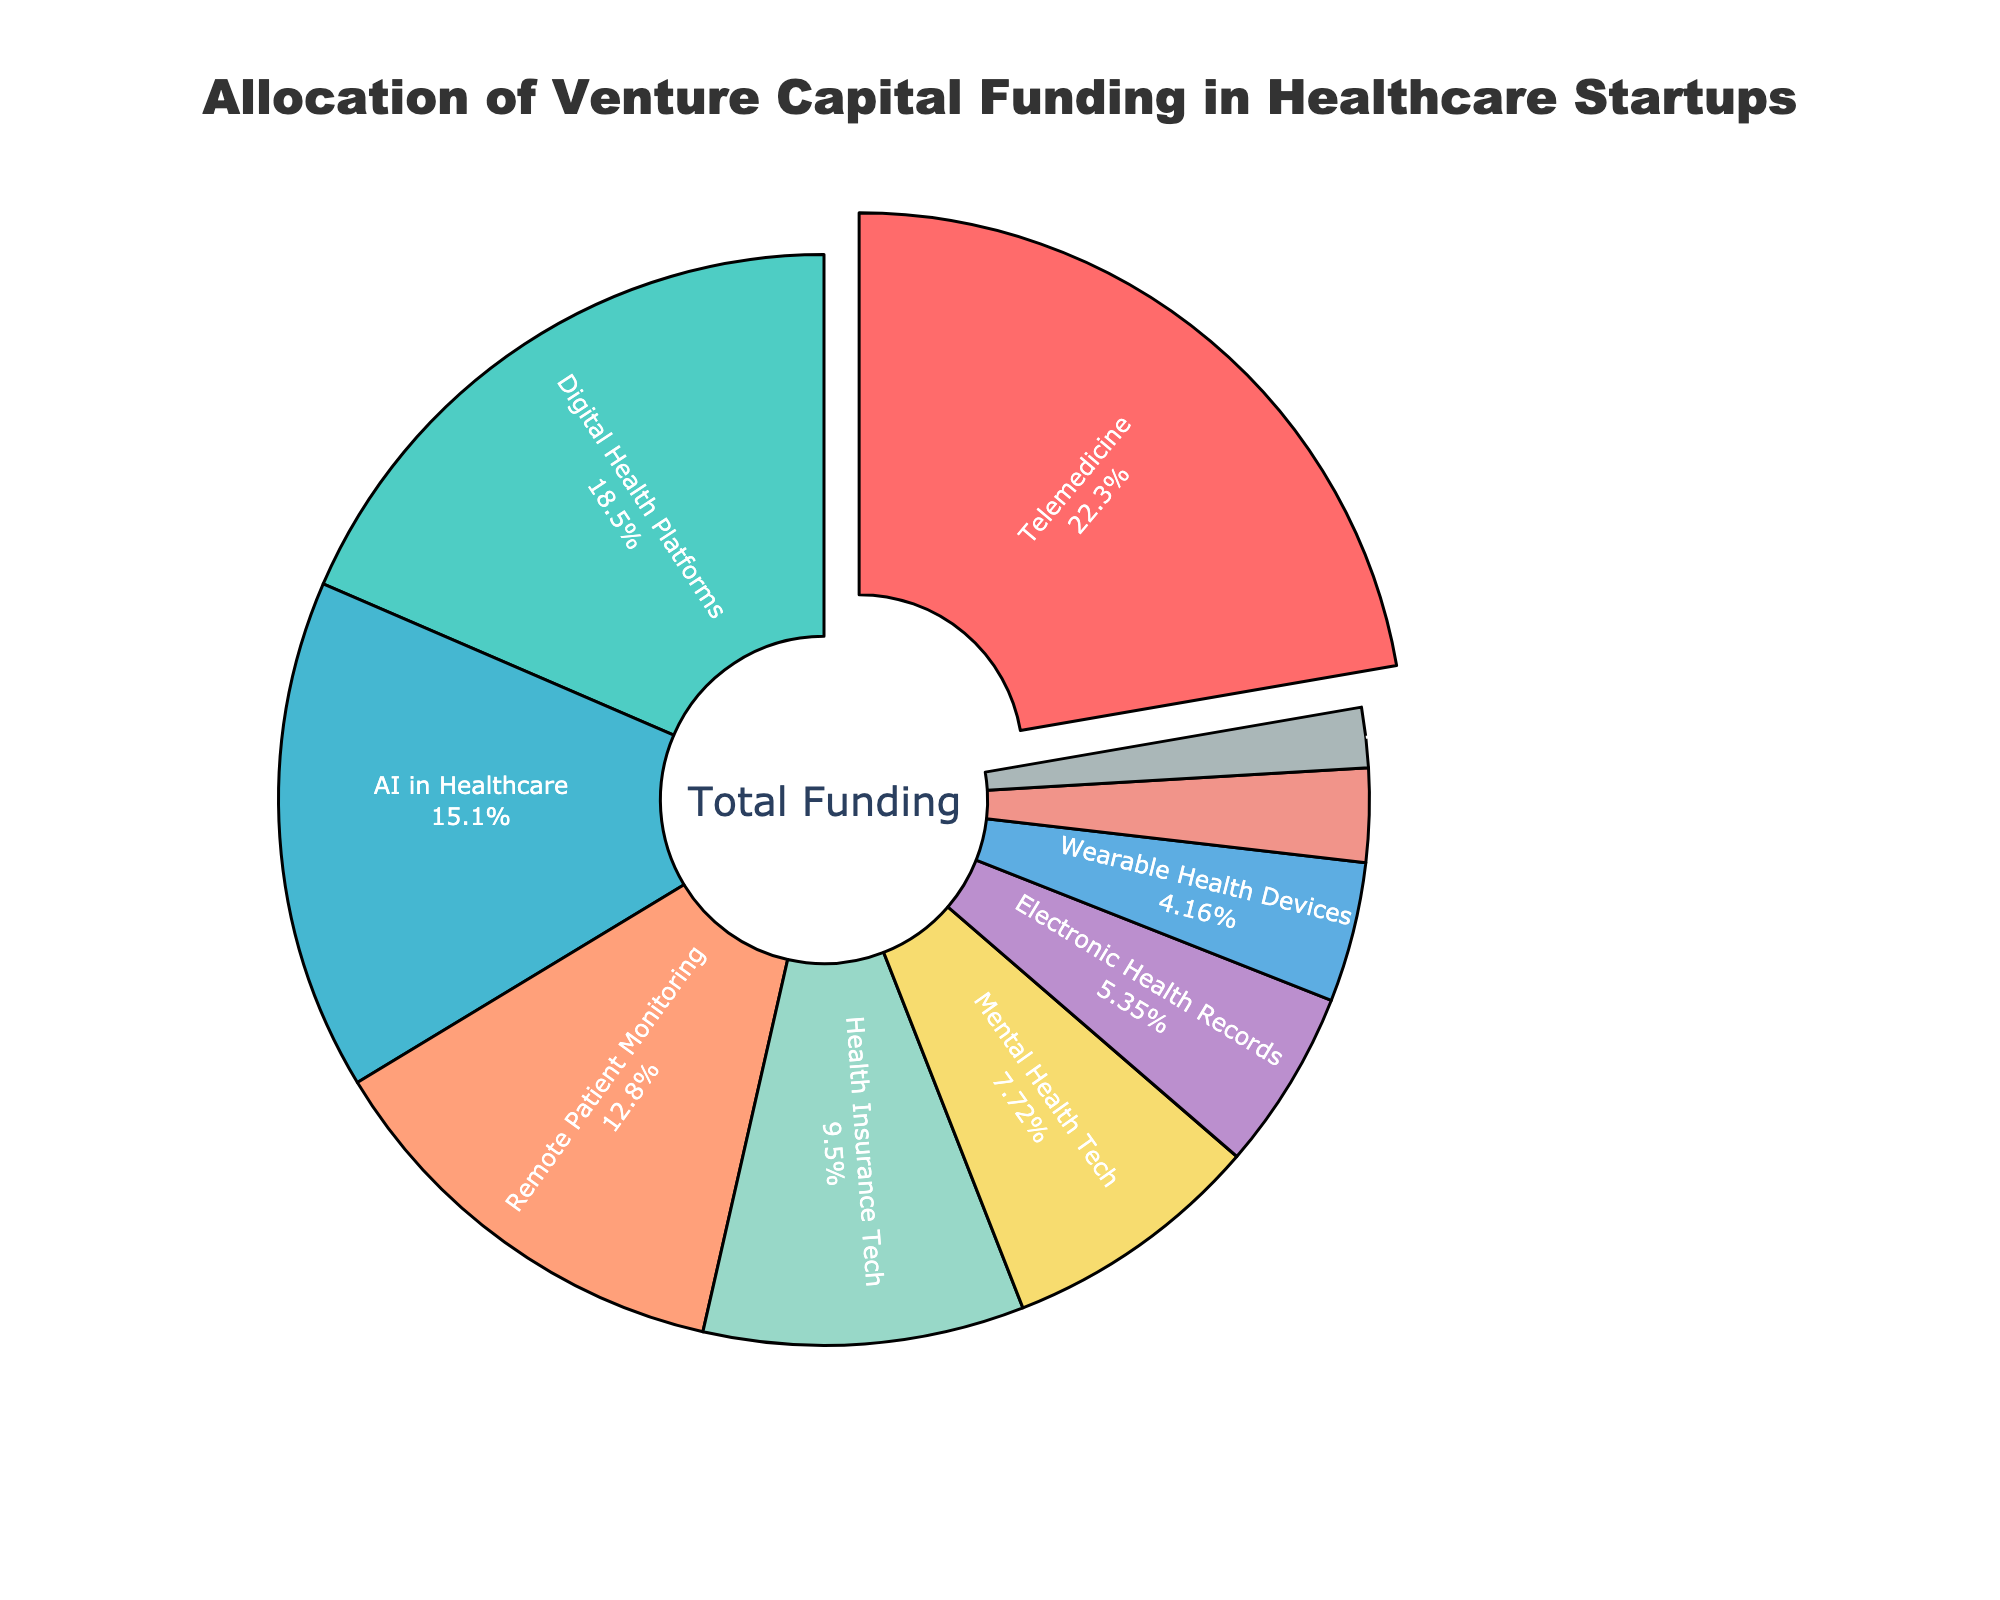What sector receives the highest percentage of venture capital funding? The sector with the largest segment on the pie chart is the one that receives the highest percentage of venture capital funding. The pulled-out segment indicates that Telemedicine receives the highest funding.
Answer: Telemedicine Which two sectors together receive more than 30% of the funding? Adding the percentages of each sector, look for two sectors whose combined total exceeds 30%. Telemedicine (22.5%) and Digital Health Platforms (18.7%) together receive 41.2% of the funding.
Answer: Telemedicine and Digital Health Platforms How much more funding does Telemedicine receive compared to Healthcare Cybersecurity? Subtract the percentage of funding allocated to Healthcare Cybersecurity from that allocated to Telemedicine. Telemedicine receives 22.5% and Healthcare Cybersecurity receives 1.8%, so the difference is 22.5% - 1.8% = 20.7%.
Answer: 20.7% Which sector receives a smaller percentage of funding: Wearable Health Devices or Personalized Medicine? Compare the percentages allocated to Wearable Health Devices (4.2%) and Personalized Medicine (2.8%), and identify the smaller one.
Answer: Personalized Medicine What is the combined funding percentage of sectors related to Health Insurance Tech and Mental Health Tech? Add the funding percentages for Health Insurance Tech (9.6%) and Mental Health Tech (7.8%). The total is 9.6% + 7.8% = 17.4%.
Answer: 17.4% What sector is represented by the light green color? Identify the segment that is light green in the color palette used in the pie chart, which corresponds to the sector with 12.9%. This sector is Remote Patient Monitoring.
Answer: Remote Patient Monitoring What is the funding percentage difference between Digital Health Platforms and AI in Healthcare? Subtract the percentage for AI in Healthcare (15.3%) from Digital Health Platforms (18.7%). The difference is 18.7% - 15.3% = 3.4%.
Answer: 3.4% How many sectors receive more than 10% of the funding? Identify and count the sectors whose funding percentages exceed 10%. These sectors are Telemedicine (22.5%), Digital Health Platforms (18.7%), AI in Healthcare (15.3%), and Remote Patient Monitoring (12.9%), totaling 4 sectors.
Answer: 4 What is the average funding percentage of the three lowest-funded sectors? Sum the percentages of the three lowest-funded sectors: Healthcare Cybersecurity (1.8%), Personalized Medicine (2.8%), and Wearable Health Devices (4.2%). Divide the total by 3 to get the average: (1.8% + 2.8% + 4.2%) / 3 = 8.8% / 3 ≈ 2.93%.
Answer: 2.93% Which sector receives slightly more than Electronic Health Records funding? Compare the percentages directly. Electronic Health Records receives 5.4%. Mental Health Tech receives 7.8%, which is slightly more.
Answer: Mental Health Tech 